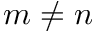Convert formula to latex. <formula><loc_0><loc_0><loc_500><loc_500>m \neq n</formula> 